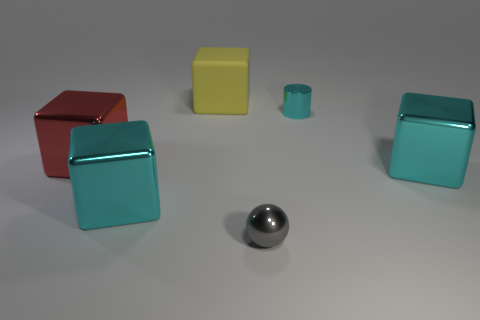What number of large shiny blocks are the same color as the shiny cylinder?
Provide a short and direct response. 2. What number of things are the same size as the yellow cube?
Give a very brief answer. 3. What number of tiny metallic things are there?
Your answer should be compact. 2. Are the tiny cyan thing and the cyan block that is left of the sphere made of the same material?
Offer a terse response. Yes. How many gray things are small metal spheres or large objects?
Make the answer very short. 1. The gray object that is made of the same material as the cylinder is what size?
Provide a succinct answer. Small. What number of tiny gray things are the same shape as the yellow object?
Offer a very short reply. 0. Are there more tiny shiny objects that are in front of the metallic cylinder than big red blocks that are to the left of the big red thing?
Make the answer very short. Yes. Do the metal cylinder and the object that is on the right side of the cylinder have the same color?
Your response must be concise. Yes. There is a cyan object that is the same size as the gray object; what material is it?
Give a very brief answer. Metal. 